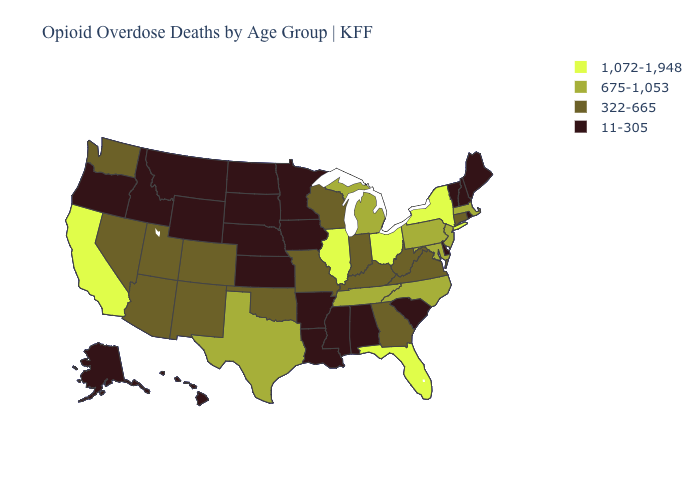Name the states that have a value in the range 1,072-1,948?
Be succinct. California, Florida, Illinois, New York, Ohio. Does the first symbol in the legend represent the smallest category?
Concise answer only. No. Does the map have missing data?
Keep it brief. No. What is the highest value in states that border Michigan?
Answer briefly. 1,072-1,948. What is the value of Oregon?
Keep it brief. 11-305. Does the map have missing data?
Short answer required. No. What is the value of Washington?
Give a very brief answer. 322-665. Which states hav the highest value in the West?
Answer briefly. California. Name the states that have a value in the range 322-665?
Answer briefly. Arizona, Colorado, Connecticut, Georgia, Indiana, Kentucky, Missouri, Nevada, New Mexico, Oklahoma, Utah, Virginia, Washington, West Virginia, Wisconsin. Does Indiana have a lower value than New York?
Be succinct. Yes. What is the value of Oklahoma?
Write a very short answer. 322-665. What is the value of Hawaii?
Quick response, please. 11-305. Among the states that border New Hampshire , does Maine have the highest value?
Be succinct. No. What is the value of California?
Quick response, please. 1,072-1,948. What is the value of Wyoming?
Be succinct. 11-305. 